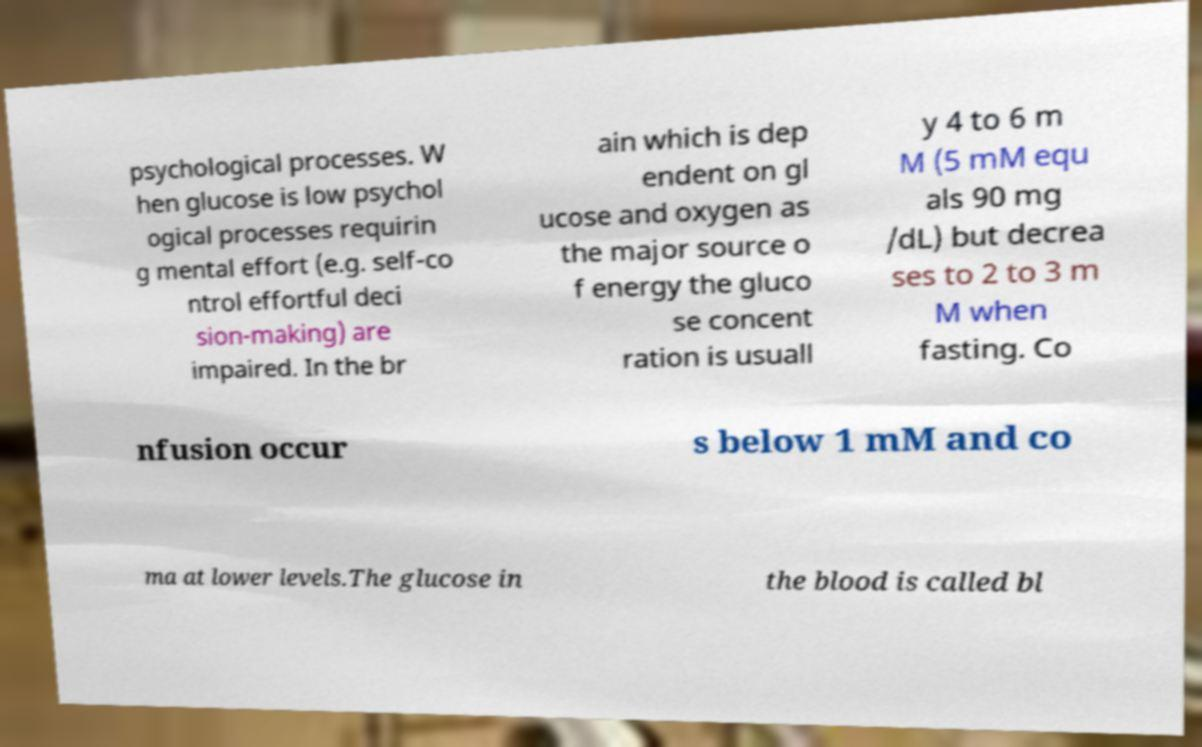Please identify and transcribe the text found in this image. psychological processes. W hen glucose is low psychol ogical processes requirin g mental effort (e.g. self-co ntrol effortful deci sion-making) are impaired. In the br ain which is dep endent on gl ucose and oxygen as the major source o f energy the gluco se concent ration is usuall y 4 to 6 m M (5 mM equ als 90 mg /dL) but decrea ses to 2 to 3 m M when fasting. Co nfusion occur s below 1 mM and co ma at lower levels.The glucose in the blood is called bl 